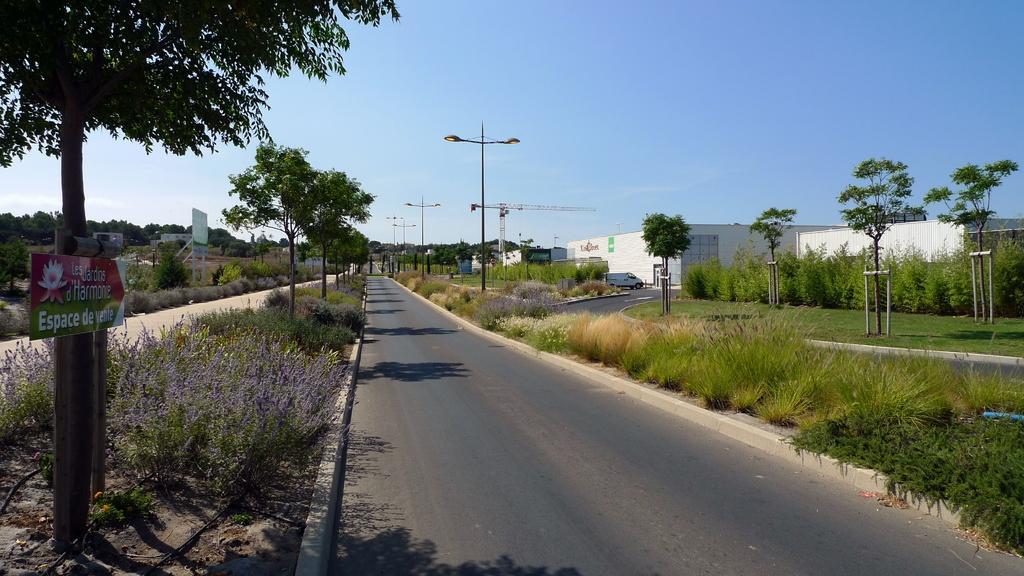Please provide a concise description of this image. In this image I can see trees in green color, light pole. At right I can see buildings in white color, at top sky is in blue color. 